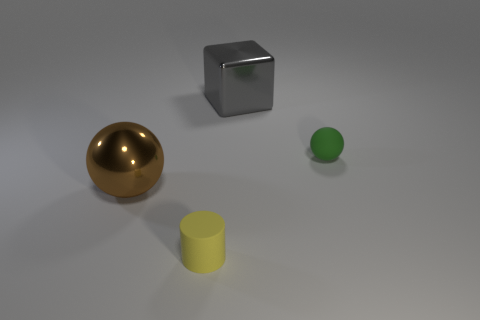Add 1 large brown rubber balls. How many objects exist? 5 Subtract all cubes. How many objects are left? 3 Add 2 gray metallic cubes. How many gray metallic cubes exist? 3 Subtract 0 purple cylinders. How many objects are left? 4 Subtract all large gray metal things. Subtract all large shiny cubes. How many objects are left? 2 Add 4 green objects. How many green objects are left? 5 